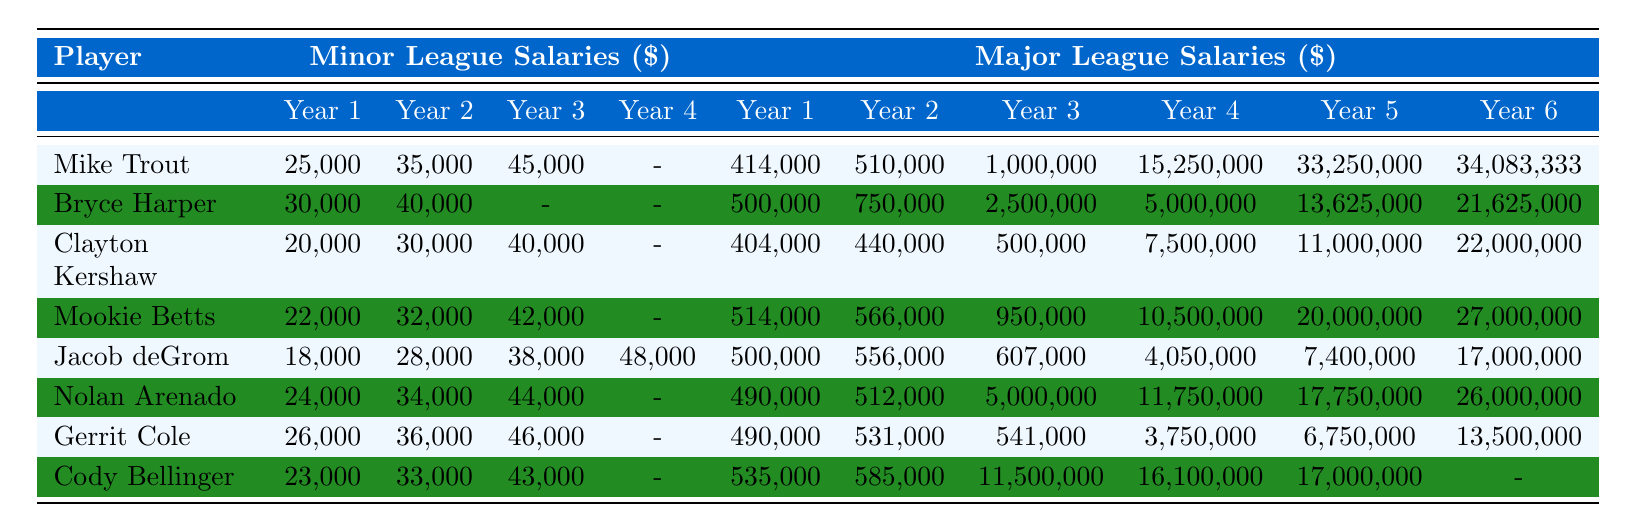What were Mike Trout's minor league salaries in his first three years? Referring to the table under "Minor League Salaries" for Mike Trout, the values are 25,000, 35,000, and 45,000 for years one, two, and three, respectively.
Answer: 25,000, 35,000, 45,000 Which player had the highest salary increase from their first to last year in the major leagues? Looking at the major league salaries, Mike Trout's first year salary is 414,000 and his last year salary is 34,083,333. To find the increase: 34,083,333 - 414,000 = 33,669,333. Comparing this with others, Bryce Harper also shows significant growth but not surpassing Trout's figure.
Answer: Mike Trout What is the average salary of Clayton Kershaw in the minor leagues? To find the average, add up Clayton’s minor league salaries: 20,000 + 30,000 + 40,000 = 90,000. Then divide by 3 (the number of years): 90,000 / 3 = 30,000.
Answer: 30,000 Did Cody Bellinger receive a salary in his sixth year as a major league player? Referring to Cody Bellinger's major league salaries, there is a dash in the sixth year column indicating he did not receive a salary.
Answer: No How much more did Mookie Betts earn in his fifth major league year compared to his second? Mookie Betts earned 20,000,000 in his fifth year and 566,000 in his second year. The difference: 20,000,000 - 566,000 = 19,434,000.
Answer: 19,434,000 What position has the highest average major league salary among the listed players? Calculate average major league salaries for each position: Outfielders: ((414,000 + 510,000 + 1,000,000 + 15,250,000 + 33,250,000 + 34,083,333) / 6), and similarly for others. The Outfielder position generally shows higher numbers, particularly Mike Trout and Bryce Harper's years play a crucial role in the average.
Answer: Outfielder Which player had a minor league salary of 18,000 in their first year? The table indicates that Jacob deGrom had a minor league salary of 18,000 in his first year.
Answer: Jacob deGrom What is the total amount of major league salary for Nolan Arenado over six years? For Nolan Arenado's major league salaries, sum them up: 490,000 + 512,000 + 5,000,000 + 11,750,000 + 17,750,000 + 26,000,000 = 61,502,000.
Answer: 61,502,000 Did Gerrit Cole's major league salary increase every single year? Checking his major league salaries, he earned 490,000, 531,000, 541,000, then 3,750,000, followed by 6,750,000, and finished with 13,500,000. Hence, the year three to year four shows a significant jump but year three does not exceed year two.
Answer: No What was the highest recorded minor league salary across all players in their first year? By inspecting the table, compare the first year minor league salaries: Mike Trout at 25,000, Bryce Harper at 30,000, Clayton Kershaw at 20,000, Mookie Betts at 22,000, Jacob deGrom at 18,000, Nolan Arenado at 24,000, Gerrit Cole at 26,000, and Cody Bellinger at 23,000. The highest is 30,000 from Bryce Harper.
Answer: 30,000 